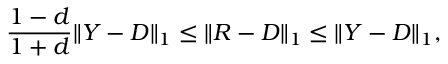Convert formula to latex. <formula><loc_0><loc_0><loc_500><loc_500>{ \frac { 1 - d } { 1 + d } } \| Y - D \| _ { 1 } \leq \| R - D \| _ { 1 } \leq \| Y - D \| _ { 1 } ,</formula> 